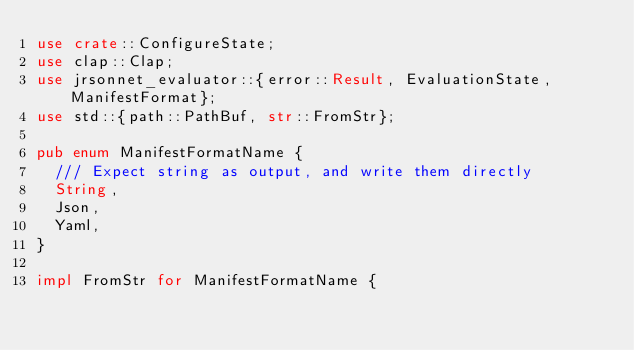<code> <loc_0><loc_0><loc_500><loc_500><_Rust_>use crate::ConfigureState;
use clap::Clap;
use jrsonnet_evaluator::{error::Result, EvaluationState, ManifestFormat};
use std::{path::PathBuf, str::FromStr};

pub enum ManifestFormatName {
	/// Expect string as output, and write them directly
	String,
	Json,
	Yaml,
}

impl FromStr for ManifestFormatName {</code> 